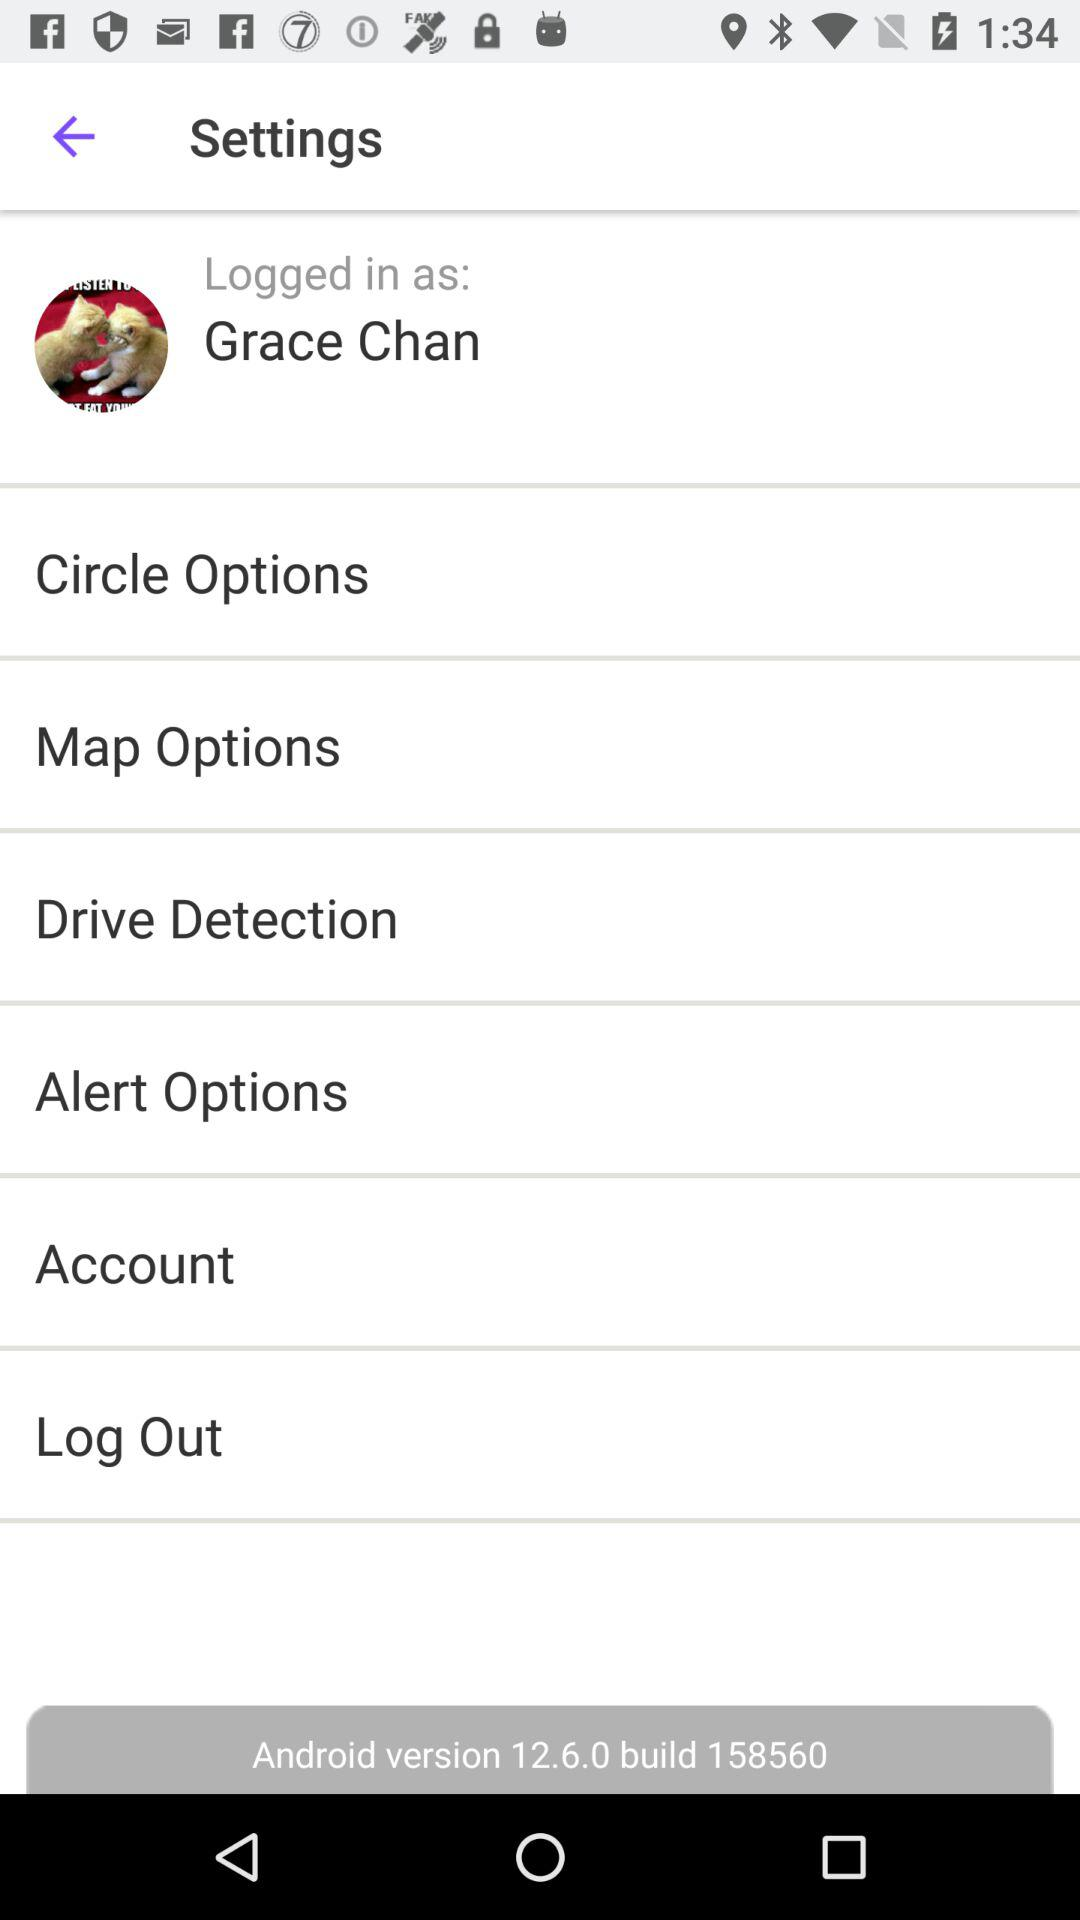What is the build number of the Android application? The build number of the Android application is 158560. 